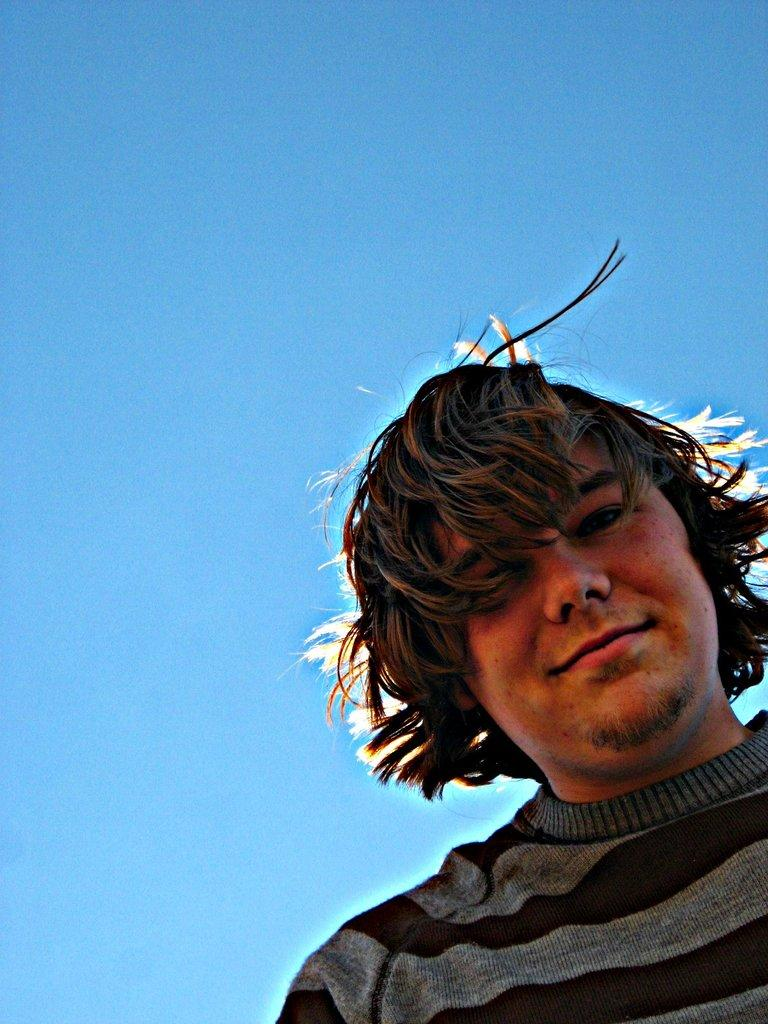Who is present in the image? There is a man in the image. What can be seen in the background of the image? The sky is blue in the background of the image. What was the weather like when the image was taken? The image was taken during a sunny day. What type of lettuce is the fireman holding in the image? There is no fireman or lettuce present in the image. 